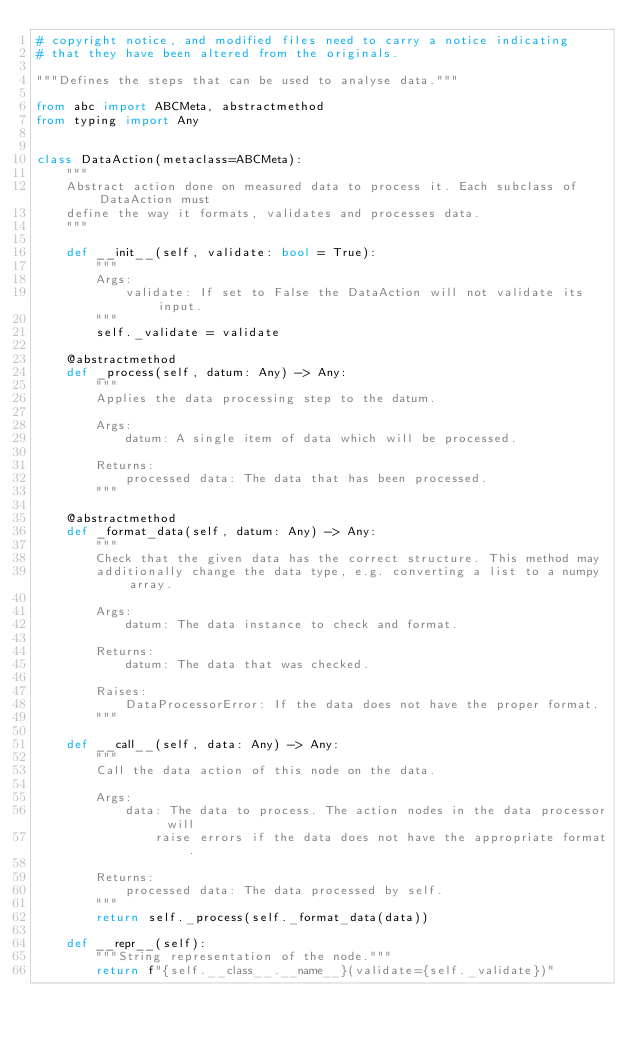Convert code to text. <code><loc_0><loc_0><loc_500><loc_500><_Python_># copyright notice, and modified files need to carry a notice indicating
# that they have been altered from the originals.

"""Defines the steps that can be used to analyse data."""

from abc import ABCMeta, abstractmethod
from typing import Any


class DataAction(metaclass=ABCMeta):
    """
    Abstract action done on measured data to process it. Each subclass of DataAction must
    define the way it formats, validates and processes data.
    """

    def __init__(self, validate: bool = True):
        """
        Args:
            validate: If set to False the DataAction will not validate its input.
        """
        self._validate = validate

    @abstractmethod
    def _process(self, datum: Any) -> Any:
        """
        Applies the data processing step to the datum.

        Args:
            datum: A single item of data which will be processed.

        Returns:
            processed data: The data that has been processed.
        """

    @abstractmethod
    def _format_data(self, datum: Any) -> Any:
        """
        Check that the given data has the correct structure. This method may
        additionally change the data type, e.g. converting a list to a numpy array.

        Args:
            datum: The data instance to check and format.

        Returns:
            datum: The data that was checked.

        Raises:
            DataProcessorError: If the data does not have the proper format.
        """

    def __call__(self, data: Any) -> Any:
        """
        Call the data action of this node on the data.

        Args:
            data: The data to process. The action nodes in the data processor will
                raise errors if the data does not have the appropriate format.

        Returns:
            processed data: The data processed by self.
        """
        return self._process(self._format_data(data))

    def __repr__(self):
        """String representation of the node."""
        return f"{self.__class__.__name__}(validate={self._validate})"
</code> 